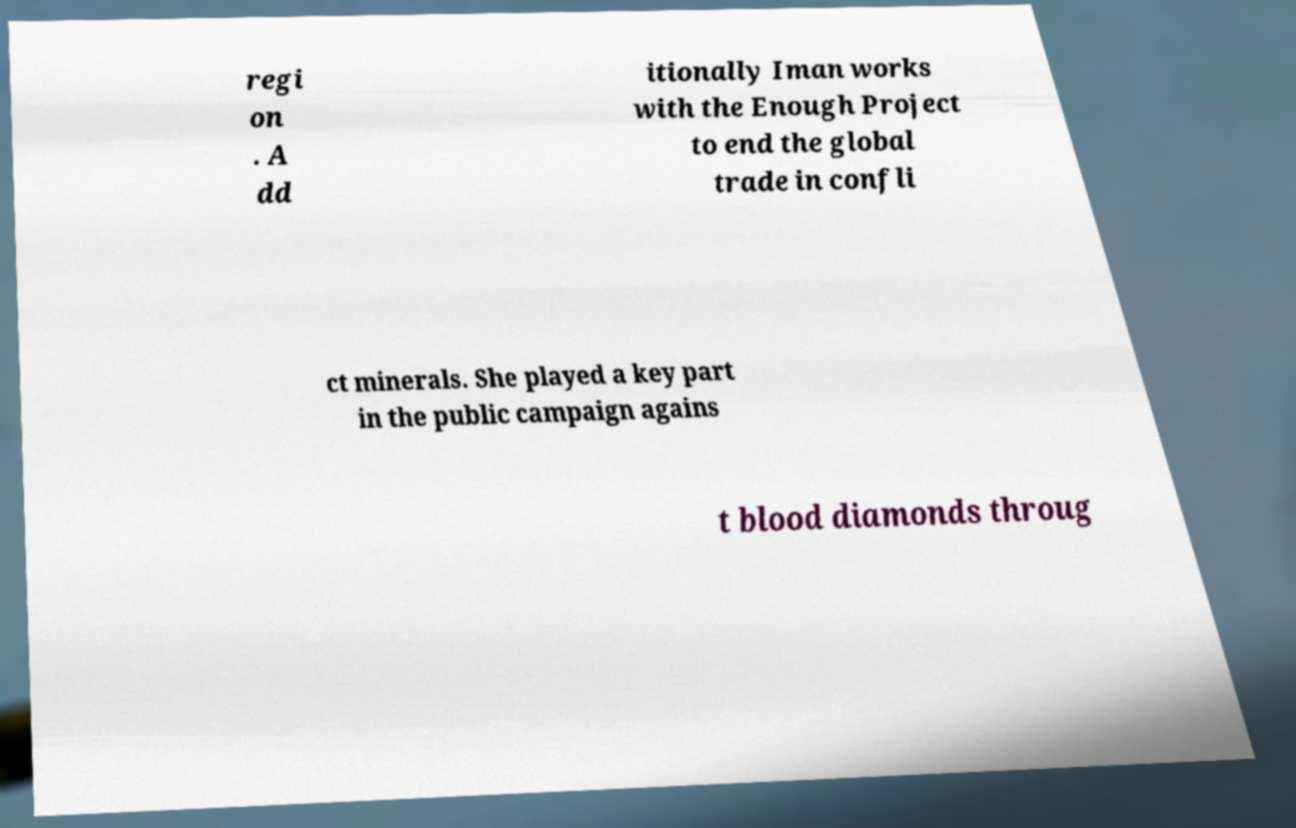Could you extract and type out the text from this image? regi on . A dd itionally Iman works with the Enough Project to end the global trade in confli ct minerals. She played a key part in the public campaign agains t blood diamonds throug 